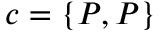Convert formula to latex. <formula><loc_0><loc_0><loc_500><loc_500>c = \{ P , P \}</formula> 